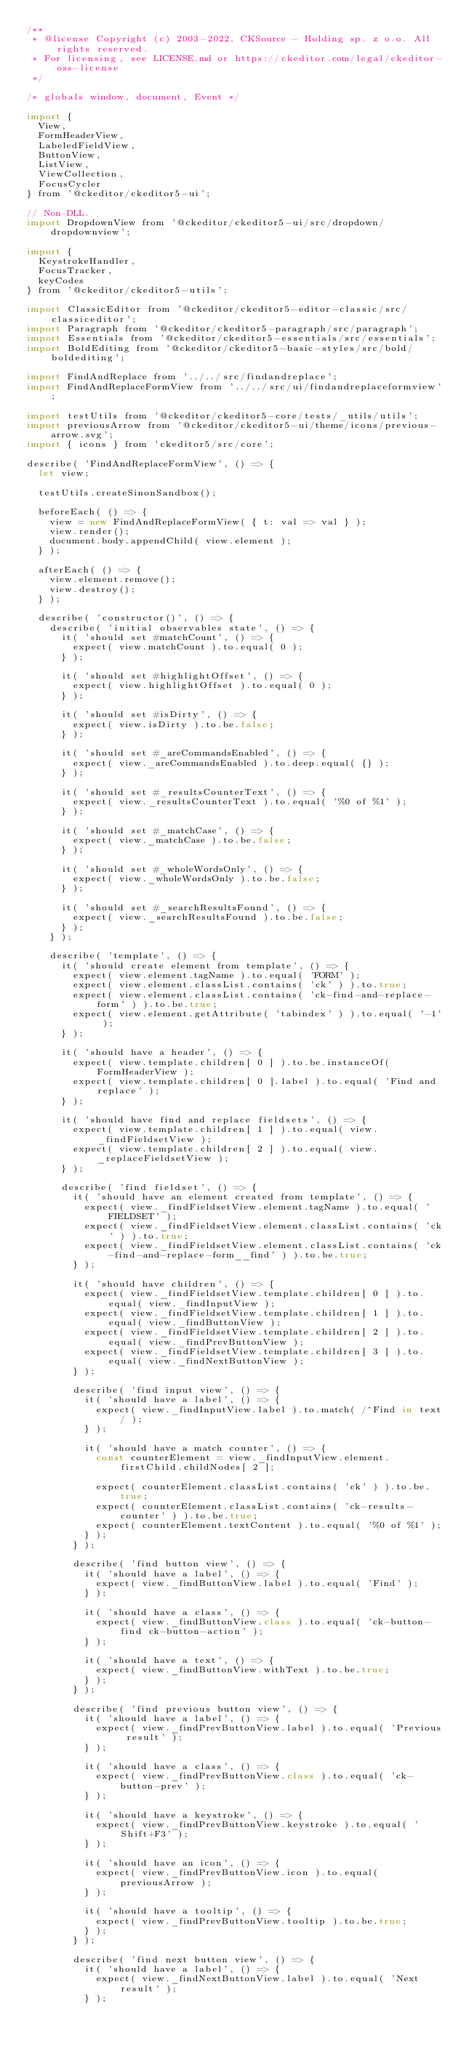<code> <loc_0><loc_0><loc_500><loc_500><_JavaScript_>/**
 * @license Copyright (c) 2003-2022, CKSource - Holding sp. z o.o. All rights reserved.
 * For licensing, see LICENSE.md or https://ckeditor.com/legal/ckeditor-oss-license
 */

/* globals window, document, Event */

import {
	View,
	FormHeaderView,
	LabeledFieldView,
	ButtonView,
	ListView,
	ViewCollection,
	FocusCycler
} from '@ckeditor/ckeditor5-ui';

// Non-DLL.
import DropdownView from '@ckeditor/ckeditor5-ui/src/dropdown/dropdownview';

import {
	KeystrokeHandler,
	FocusTracker,
	keyCodes
} from '@ckeditor/ckeditor5-utils';

import ClassicEditor from '@ckeditor/ckeditor5-editor-classic/src/classiceditor';
import Paragraph from '@ckeditor/ckeditor5-paragraph/src/paragraph';
import Essentials from '@ckeditor/ckeditor5-essentials/src/essentials';
import BoldEditing from '@ckeditor/ckeditor5-basic-styles/src/bold/boldediting';

import FindAndReplace from '../../src/findandreplace';
import FindAndReplaceFormView from '../../src/ui/findandreplaceformview';

import testUtils from '@ckeditor/ckeditor5-core/tests/_utils/utils';
import previousArrow from '@ckeditor/ckeditor5-ui/theme/icons/previous-arrow.svg';
import { icons } from 'ckeditor5/src/core';

describe( 'FindAndReplaceFormView', () => {
	let view;

	testUtils.createSinonSandbox();

	beforeEach( () => {
		view = new FindAndReplaceFormView( { t: val => val } );
		view.render();
		document.body.appendChild( view.element );
	} );

	afterEach( () => {
		view.element.remove();
		view.destroy();
	} );

	describe( 'constructor()', () => {
		describe( 'initial observables state', () => {
			it( 'should set #matchCount', () => {
				expect( view.matchCount ).to.equal( 0 );
			} );

			it( 'should set #highlightOffset', () => {
				expect( view.highlightOffset ).to.equal( 0 );
			} );

			it( 'should set #isDirty', () => {
				expect( view.isDirty ).to.be.false;
			} );

			it( 'should set #_areCommandsEnabled', () => {
				expect( view._areCommandsEnabled ).to.deep.equal( {} );
			} );

			it( 'should set #_resultsCounterText', () => {
				expect( view._resultsCounterText ).to.equal( '%0 of %1' );
			} );

			it( 'should set #_matchCase', () => {
				expect( view._matchCase ).to.be.false;
			} );

			it( 'should set #_wholeWordsOnly', () => {
				expect( view._wholeWordsOnly ).to.be.false;
			} );

			it( 'should set #_searchResultsFound', () => {
				expect( view._searchResultsFound ).to.be.false;
			} );
		} );

		describe( 'template', () => {
			it( 'should create element from template', () => {
				expect( view.element.tagName ).to.equal( 'FORM' );
				expect( view.element.classList.contains( 'ck' ) ).to.true;
				expect( view.element.classList.contains( 'ck-find-and-replace-form' ) ).to.be.true;
				expect( view.element.getAttribute( 'tabindex' ) ).to.equal( '-1' );
			} );

			it( 'should have a header', () => {
				expect( view.template.children[ 0 ] ).to.be.instanceOf( FormHeaderView );
				expect( view.template.children[ 0 ].label ).to.equal( 'Find and replace' );
			} );

			it( 'should have find and replace fieldsets', () => {
				expect( view.template.children[ 1 ] ).to.equal( view._findFieldsetView );
				expect( view.template.children[ 2 ] ).to.equal( view._replaceFieldsetView );
			} );

			describe( 'find fieldset', () => {
				it( 'should have an element created from template', () => {
					expect( view._findFieldsetView.element.tagName ).to.equal( 'FIELDSET' );
					expect( view._findFieldsetView.element.classList.contains( 'ck' ) ).to.true;
					expect( view._findFieldsetView.element.classList.contains( 'ck-find-and-replace-form__find' ) ).to.be.true;
				} );

				it( 'should have children', () => {
					expect( view._findFieldsetView.template.children[ 0 ] ).to.equal( view._findInputView );
					expect( view._findFieldsetView.template.children[ 1 ] ).to.equal( view._findButtonView );
					expect( view._findFieldsetView.template.children[ 2 ] ).to.equal( view._findPrevButtonView );
					expect( view._findFieldsetView.template.children[ 3 ] ).to.equal( view._findNextButtonView );
				} );

				describe( 'find input view', () => {
					it( 'should have a label', () => {
						expect( view._findInputView.label ).to.match( /^Find in text/ );
					} );

					it( 'should have a match counter', () => {
						const counterElement = view._findInputView.element.firstChild.childNodes[ 2 ];

						expect( counterElement.classList.contains( 'ck' ) ).to.be.true;
						expect( counterElement.classList.contains( 'ck-results-counter' ) ).to.be.true;
						expect( counterElement.textContent ).to.equal( '%0 of %1' );
					} );
				} );

				describe( 'find button view', () => {
					it( 'should have a label', () => {
						expect( view._findButtonView.label ).to.equal( 'Find' );
					} );

					it( 'should have a class', () => {
						expect( view._findButtonView.class ).to.equal( 'ck-button-find ck-button-action' );
					} );

					it( 'should have a text', () => {
						expect( view._findButtonView.withText ).to.be.true;
					} );
				} );

				describe( 'find previous button view', () => {
					it( 'should have a label', () => {
						expect( view._findPrevButtonView.label ).to.equal( 'Previous result' );
					} );

					it( 'should have a class', () => {
						expect( view._findPrevButtonView.class ).to.equal( 'ck-button-prev' );
					} );

					it( 'should have a keystroke', () => {
						expect( view._findPrevButtonView.keystroke ).to.equal( 'Shift+F3' );
					} );

					it( 'should have an icon', () => {
						expect( view._findPrevButtonView.icon ).to.equal( previousArrow );
					} );

					it( 'should have a tooltip', () => {
						expect( view._findPrevButtonView.tooltip ).to.be.true;
					} );
				} );

				describe( 'find next button view', () => {
					it( 'should have a label', () => {
						expect( view._findNextButtonView.label ).to.equal( 'Next result' );
					} );
</code> 